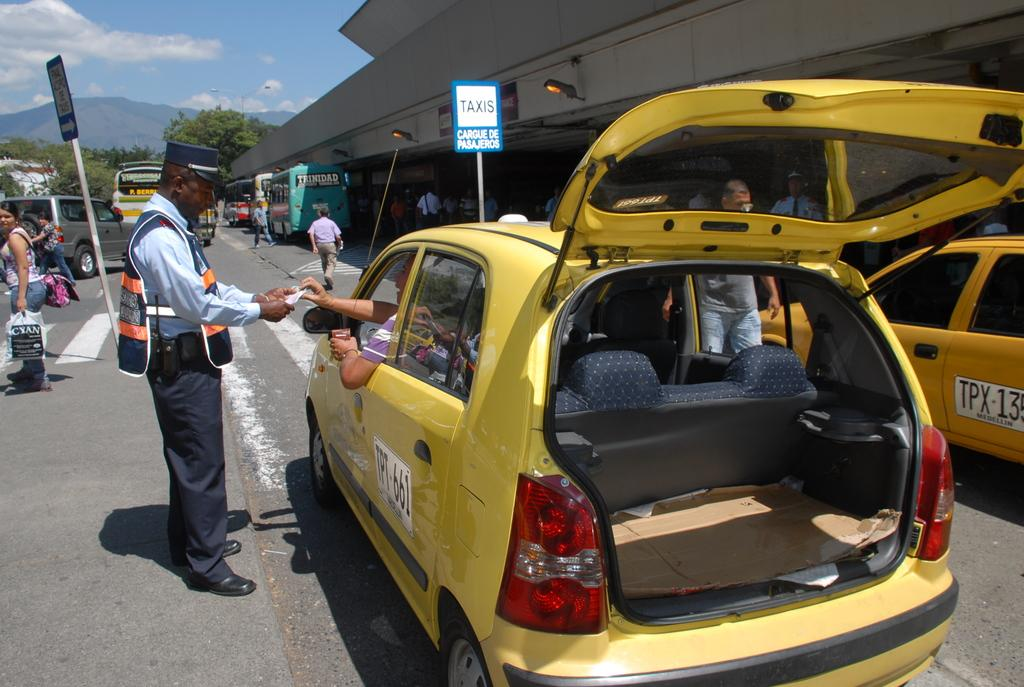<image>
Offer a succinct explanation of the picture presented. Yellow taxis are next to a parking lot by a sign that says Taxis. 